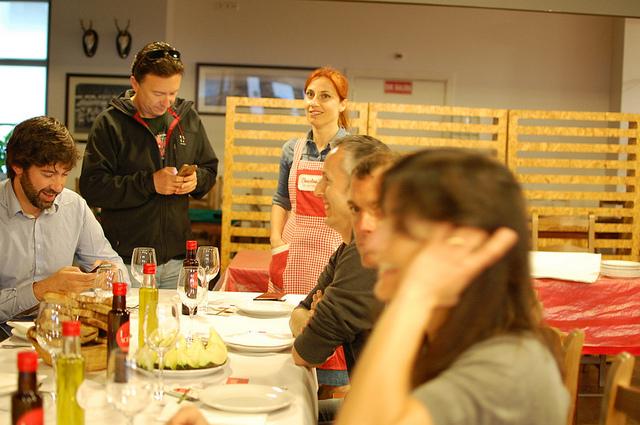What is the red-haired lady wearing?
Be succinct. Apron. Is there food on the plate?
Short answer required. No. Why does the woman have her hand to her face?
Quick response, please. She is tucking her hair back. 